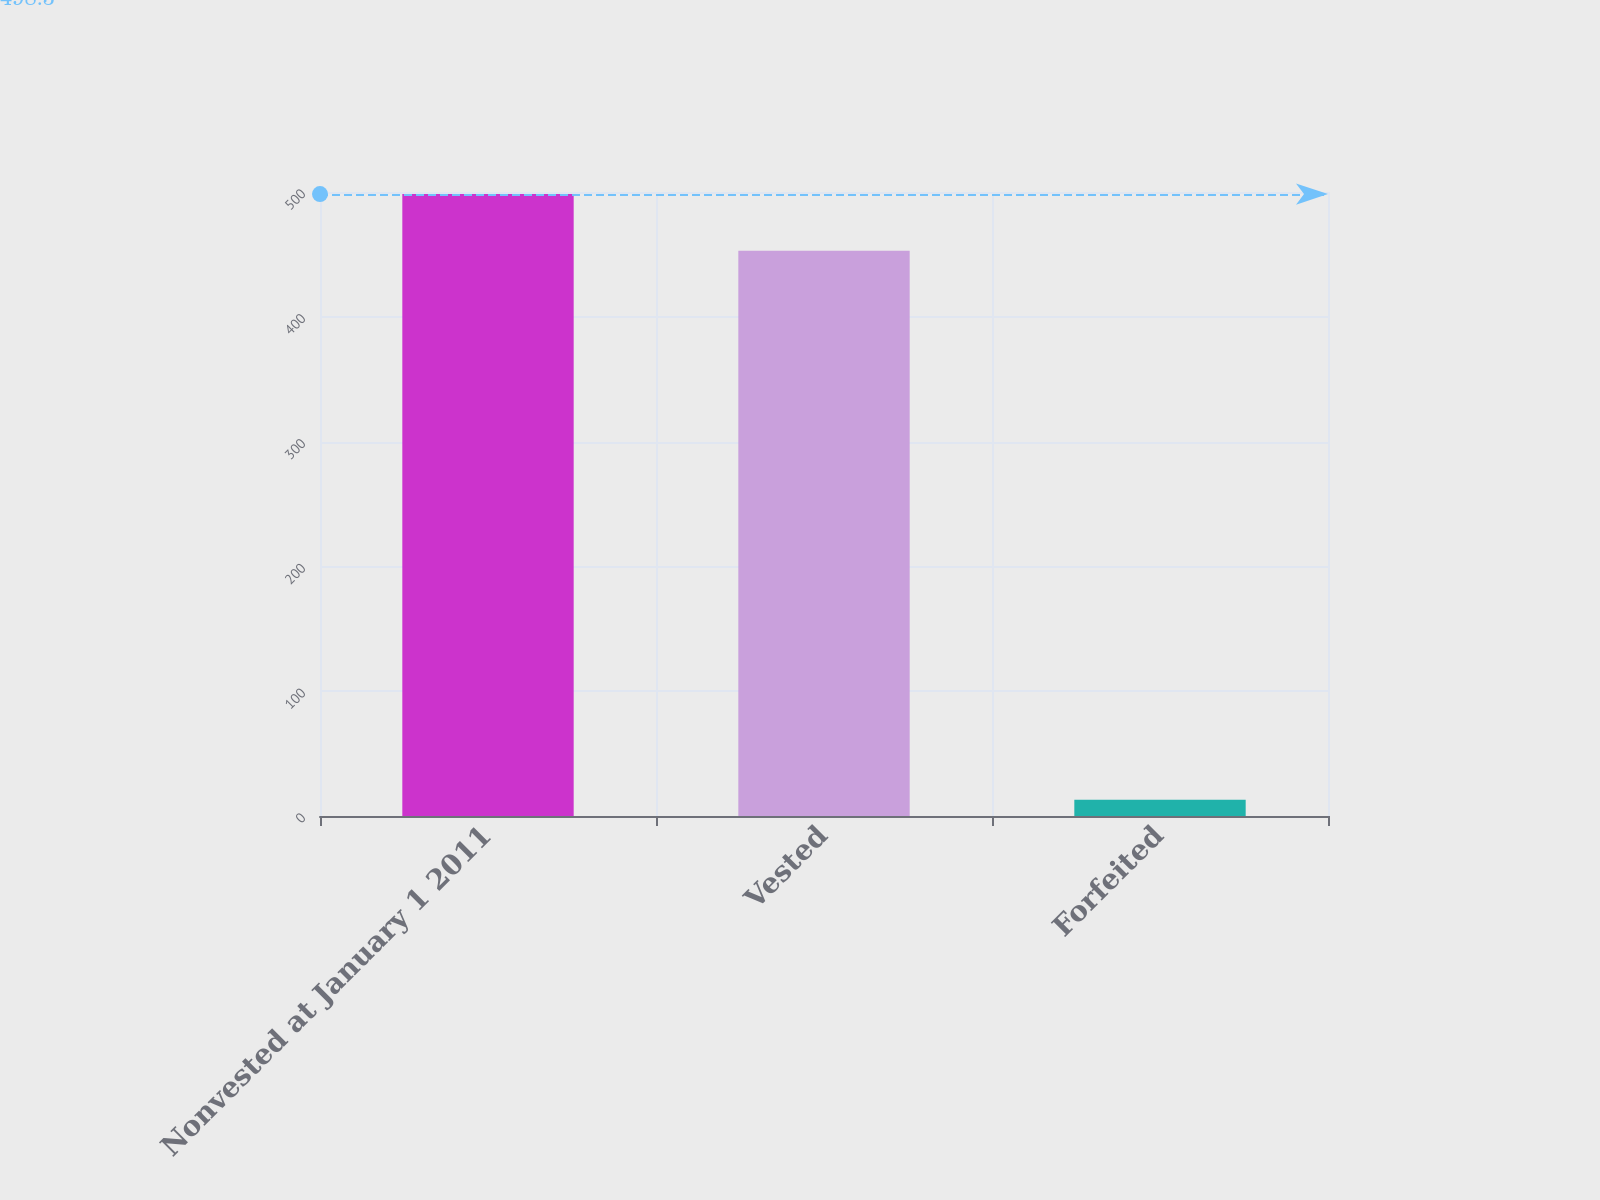<chart> <loc_0><loc_0><loc_500><loc_500><bar_chart><fcel>Nonvested at January 1 2011<fcel>Vested<fcel>Forfeited<nl><fcel>498.3<fcel>453<fcel>13<nl></chart> 